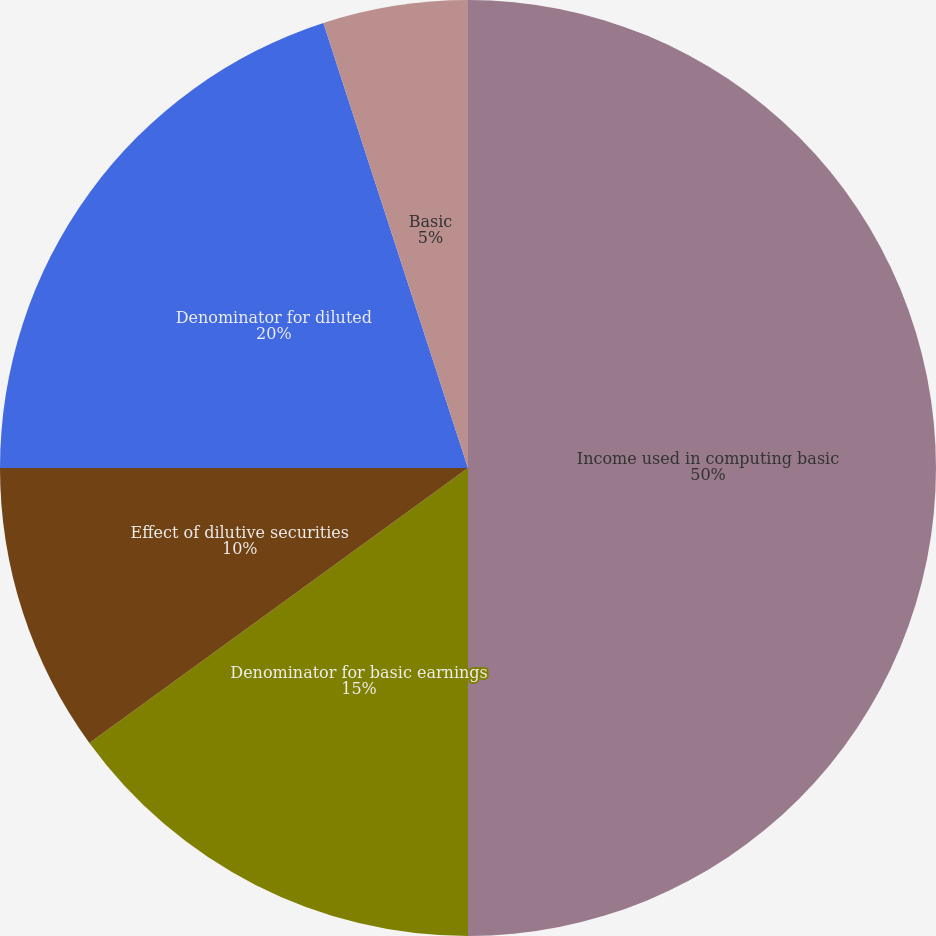Convert chart to OTSL. <chart><loc_0><loc_0><loc_500><loc_500><pie_chart><fcel>Income used in computing basic<fcel>Denominator for basic earnings<fcel>Effect of dilutive securities<fcel>Denominator for diluted<fcel>Basic<fcel>Diluted<nl><fcel>50.0%<fcel>15.0%<fcel>10.0%<fcel>20.0%<fcel>5.0%<fcel>0.0%<nl></chart> 